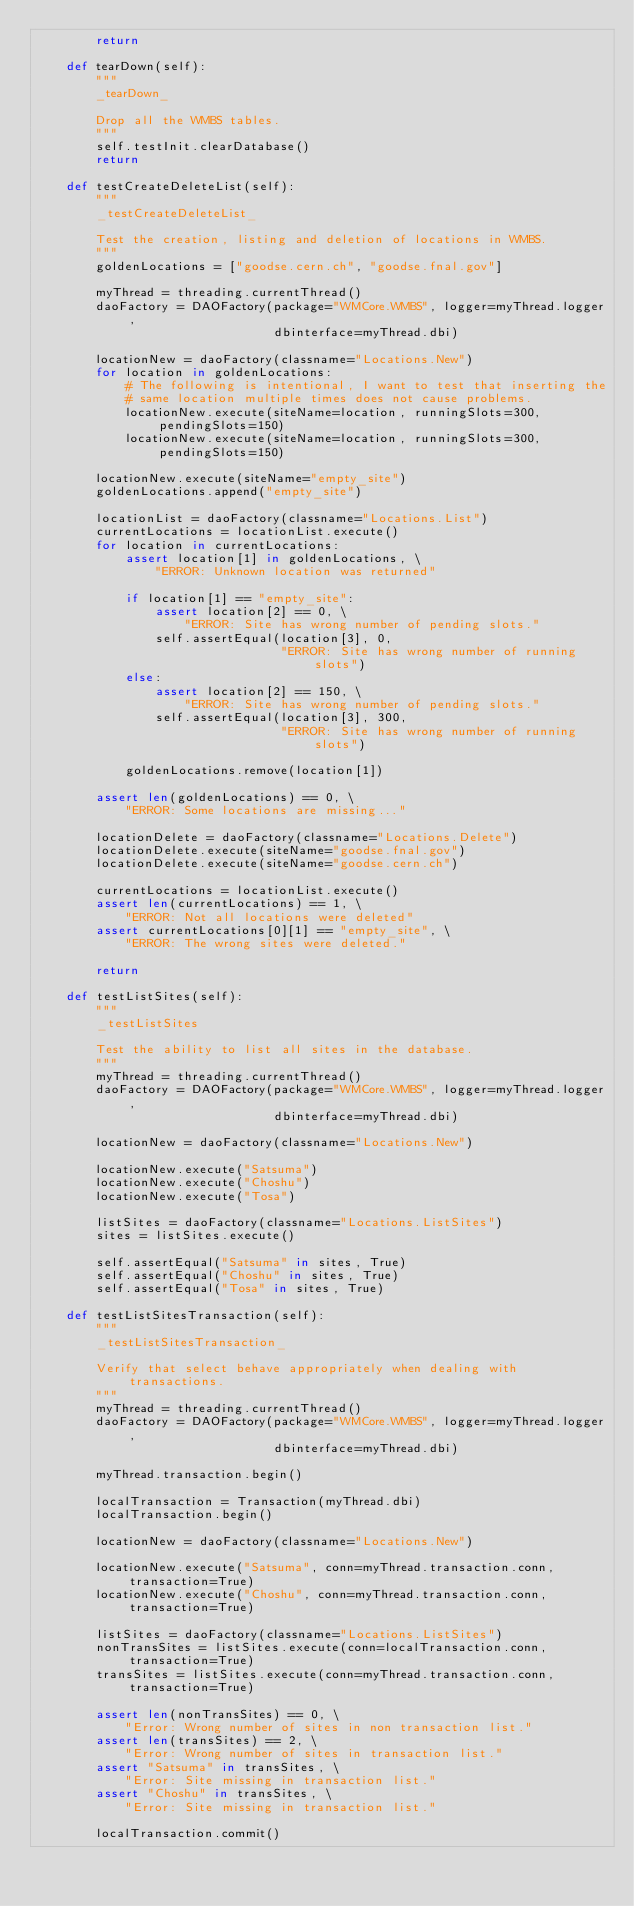Convert code to text. <code><loc_0><loc_0><loc_500><loc_500><_Python_>        return

    def tearDown(self):
        """
        _tearDown_

        Drop all the WMBS tables.
        """
        self.testInit.clearDatabase()
        return

    def testCreateDeleteList(self):
        """
        _testCreateDeleteList_

        Test the creation, listing and deletion of locations in WMBS.
        """
        goldenLocations = ["goodse.cern.ch", "goodse.fnal.gov"]

        myThread = threading.currentThread()
        daoFactory = DAOFactory(package="WMCore.WMBS", logger=myThread.logger,
                                dbinterface=myThread.dbi)

        locationNew = daoFactory(classname="Locations.New")
        for location in goldenLocations:
            # The following is intentional, I want to test that inserting the
            # same location multiple times does not cause problems.
            locationNew.execute(siteName=location, runningSlots=300, pendingSlots=150)
            locationNew.execute(siteName=location, runningSlots=300, pendingSlots=150)

        locationNew.execute(siteName="empty_site")
        goldenLocations.append("empty_site")

        locationList = daoFactory(classname="Locations.List")
        currentLocations = locationList.execute()
        for location in currentLocations:
            assert location[1] in goldenLocations, \
                "ERROR: Unknown location was returned"

            if location[1] == "empty_site":
                assert location[2] == 0, \
                    "ERROR: Site has wrong number of pending slots."
                self.assertEqual(location[3], 0,
                                 "ERROR: Site has wrong number of running slots")
            else:
                assert location[2] == 150, \
                    "ERROR: Site has wrong number of pending slots."
                self.assertEqual(location[3], 300,
                                 "ERROR: Site has wrong number of running slots")

            goldenLocations.remove(location[1])

        assert len(goldenLocations) == 0, \
            "ERROR: Some locations are missing..."

        locationDelete = daoFactory(classname="Locations.Delete")
        locationDelete.execute(siteName="goodse.fnal.gov")
        locationDelete.execute(siteName="goodse.cern.ch")

        currentLocations = locationList.execute()
        assert len(currentLocations) == 1, \
            "ERROR: Not all locations were deleted"
        assert currentLocations[0][1] == "empty_site", \
            "ERROR: The wrong sites were deleted."

        return

    def testListSites(self):
        """
        _testListSites

        Test the ability to list all sites in the database.
        """
        myThread = threading.currentThread()
        daoFactory = DAOFactory(package="WMCore.WMBS", logger=myThread.logger,
                                dbinterface=myThread.dbi)

        locationNew = daoFactory(classname="Locations.New")

        locationNew.execute("Satsuma")
        locationNew.execute("Choshu")
        locationNew.execute("Tosa")

        listSites = daoFactory(classname="Locations.ListSites")
        sites = listSites.execute()

        self.assertEqual("Satsuma" in sites, True)
        self.assertEqual("Choshu" in sites, True)
        self.assertEqual("Tosa" in sites, True)

    def testListSitesTransaction(self):
        """
        _testListSitesTransaction_

        Verify that select behave appropriately when dealing with transactions.
        """
        myThread = threading.currentThread()
        daoFactory = DAOFactory(package="WMCore.WMBS", logger=myThread.logger,
                                dbinterface=myThread.dbi)

        myThread.transaction.begin()

        localTransaction = Transaction(myThread.dbi)
        localTransaction.begin()

        locationNew = daoFactory(classname="Locations.New")

        locationNew.execute("Satsuma", conn=myThread.transaction.conn, transaction=True)
        locationNew.execute("Choshu", conn=myThread.transaction.conn, transaction=True)

        listSites = daoFactory(classname="Locations.ListSites")
        nonTransSites = listSites.execute(conn=localTransaction.conn, transaction=True)
        transSites = listSites.execute(conn=myThread.transaction.conn, transaction=True)

        assert len(nonTransSites) == 0, \
            "Error: Wrong number of sites in non transaction list."
        assert len(transSites) == 2, \
            "Error: Wrong number of sites in transaction list."
        assert "Satsuma" in transSites, \
            "Error: Site missing in transaction list."
        assert "Choshu" in transSites, \
            "Error: Site missing in transaction list."

        localTransaction.commit()</code> 